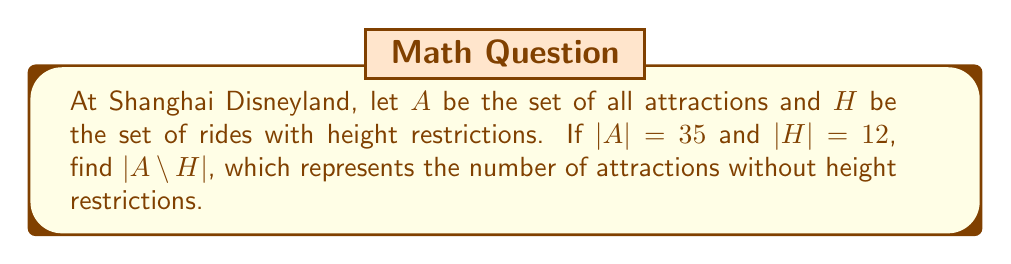Provide a solution to this math problem. To solve this problem, we need to understand the concept of set complement and use the given information:

1. $A$ is the universal set (all attractions at Shanghai Disneyland)
2. $H$ is the set of rides with height restrictions
3. $A \setminus H$ is the complement of $H$ with respect to $A$, representing attractions without height restrictions

We are given:
- $|A| = 35$ (total number of attractions)
- $|H| = 12$ (number of rides with height restrictions)

To find $|A \setminus H|$, we can use the following relationship:

$$|A \setminus H| = |A| - |H|$$

This is because the complement of $H$ in $A$ includes all elements in $A$ that are not in $H$.

Substituting the given values:

$$|A \setminus H| = 35 - 12 = 23$$

Therefore, there are 23 attractions without height restrictions at Shanghai Disneyland.
Answer: $|A \setminus H| = 23$ 